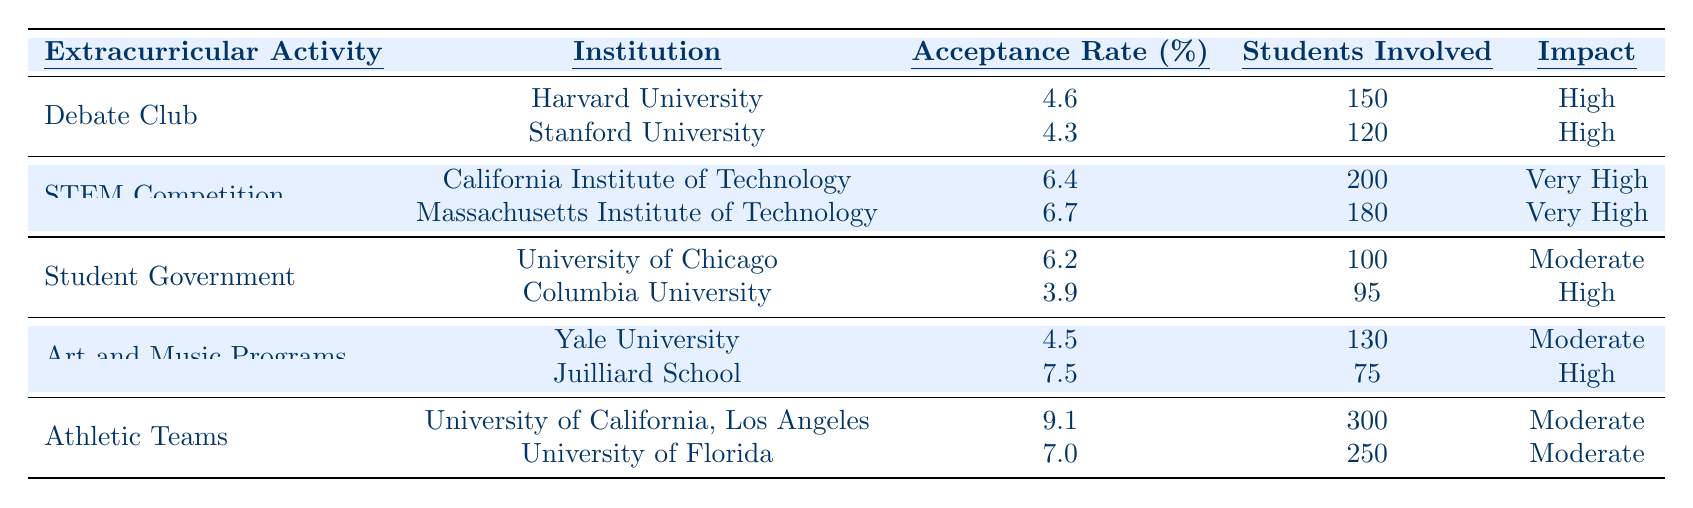What is the acceptance rate for Stanford University? The table lists Stanford University under the "Debate Club" activity, with an acceptance rate of 4.3%.
Answer: 4.3% Which extracurricular activity has the highest impact rating? The "STEM Competition" extracurricular activity is noted to have a "Very High" impact rating, based on the institutions listed.
Answer: STEM Competition How many students are involved in the Debate Club at Harvard University? According to the table, Harvard University has 150 students involved in the Debate Club.
Answer: 150 What is the average acceptance rate for institutions in the Art and Music Programs? The acceptance rates for Yale University (4.5%) and Juilliard School (7.5%) can be averaged: (4.5 + 7.5) / 2 = 6.0%.
Answer: 6.0% Is the acceptance rate for the University of Florida higher than that for the University of California, Los Angeles? The acceptance rate for the University of Florida is 7.0%, while the rate for UCLA is 9.1%. Since 7.0% is lower than 9.1%, the statement is false.
Answer: No Which activity involves the most students? The "Athletic Teams" activity has 300 students involved at the University of California, Los Angeles, which is higher than any other activity.
Answer: Athletic Teams What impact rating do both institutions under the Student Government activity have? University of Chicago has a "Moderate" impact, while Columbia University has a "High" impact rating, reflecting different levels of influence on college acceptance.
Answer: Moderate and High If we consider only the institutions with a "High" impact, what is the average acceptance rate? The institutions with a High impact are Columbia University (3.9%) and Juilliard School (7.5%). Their average acceptance rate is (3.9 + 7.5) / 2 = 5.7%.
Answer: 5.7% Which extracurricular activity has the least number of students involved? The Juilliard School under the "Art and Music Programs" has the least number of students involved at 75.
Answer: Art and Music Programs What is the total number of students involved across all activities? By adding the students involved: 150 + 120 + 200 + 180 + 100 + 95 + 130 + 75 + 300 + 250 = 1500.
Answer: 1500 